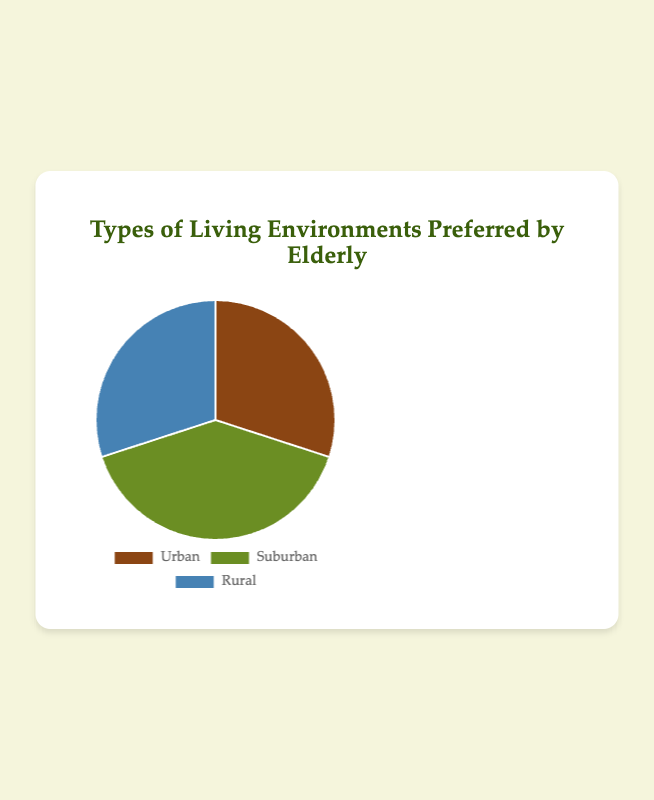Which living environment is preferred the most by the elderly? The Suburban environment is preferred the most since it has the highest percentage at 40%.
Answer: Suburban Which two living environments have the same percentage of preference among the elderly? Both Urban and Rural environments have the same percentage preference of 30%.
Answer: Urban and Rural How much more is the preference for Suburban living compared to Urban living? The preference for Suburban living is 40% while Urban is 30%, so the difference is 40% - 30% = 10%.
Answer: 10% What is the total percentage of elderly who prefer Urban and Rural living environments combined? Adding the percentages for Urban and Rural gives 30% + 30% = 60%.
Answer: 60% What color represents the Urban living environment in the chart? The color representing Urban living is brown.
Answer: Brown What is the average percentage of preference across all three living environments? Adding the percentages for all environments gives 30% (Urban) + 40% (Suburban) + 30% (Rural) = 100%. Dividing by 3 environments, 100% / 3 ≈ 33.33%.
Answer: 33.33% Which living environment has a higher preference: Urban or Rural? Both Urban and Rural have the same preference percentage at 30%.
Answer: Equal What percentage of the elderly prefer living environments other than Urban? The percentage is the sum of Suburban and Rural environments: 40% + 30% = 70%.
Answer: 70% How much less is the preference for Rural living compared to Suburban living? The preference for Rural is 30%, and for Suburban, it is 40%. So, the difference is 40% - 30% = 10%.
Answer: 10% 